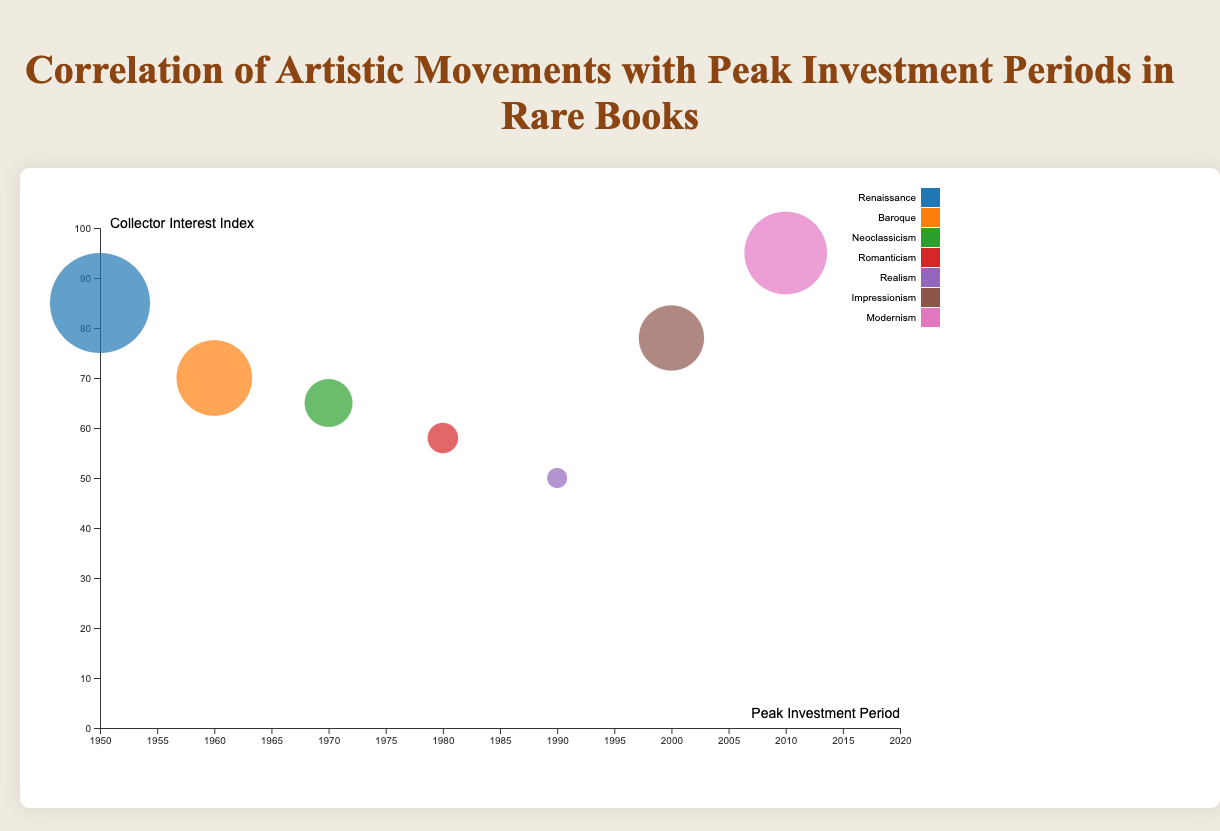What is the peak investment period for "Ulysses"? The data shows the peak investment period for "Ulysses" is between 2010 and 2020. Look at the bubbles where the title is visible and locate "Ulysses".
Answer: 2010-2020 What artistic movement corresponds to the highest collector interest index? To find the highest value on the y-axis (collector interest index) and check the label next to the corresponding bubble for the artistic movement. We see that the highest index value is near "Modernism".
Answer: Modernism Which book has the largest bubble size? By identifying the largest bubble on the chart, we see that "The Divine Comedy" has the largest bubble size at 45.
Answer: The Divine Comedy What is the average auction price for "Principia Mathematica"? Locate the bubble for "Principia Mathematica" and refer to the tooltip information or the dataset that indicates an average auction price of $800,000.
Answer: $800,000 How many years are included in the x-axis range? The x-axis represents the peak investment periods from 1950 to 2020. Calculate the difference: 2020 - 1950 = 70 years.
Answer: 70 years Which book has both an auction price higher than $1,000,000 and a collector interest index above 80? Look for bubbles with auction prices over $1,000,000 and check the y-axis values. Only "The Divine Comedy" matches this criterion.
Answer: The Divine Comedy Compare the average auction prices of "Leaves of Grass" and "Madame Bovary". Which one is higher, and by how much? From the dataset, "Leaves of Grass" has an average auction price of $450,000 while "Madame Bovary" has $380,000. Calculate the difference: $450,000 - $380,000 = $70,000.
Answer: Leaves of Grass by $70,000 What is the bubble size for the book with the author Miguel de Cervantes? Find the book "Don Quixote" authored by Miguel de Cervantes in the data, and then refer to the bubble size field which lists it as 30.
Answer: 30 